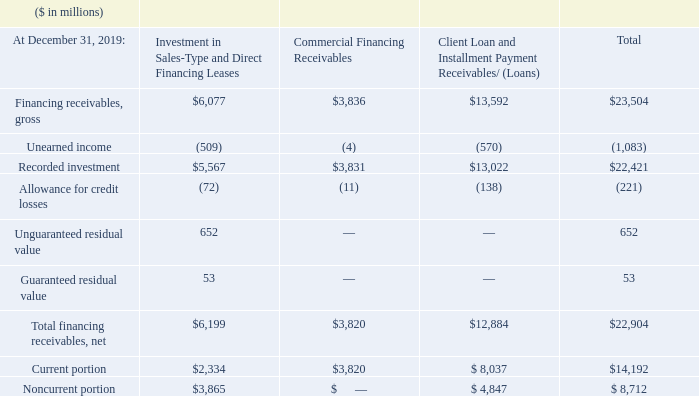Financing receivables primarily consist of client loan and installment payment receivables (loans), investment in sales-type and direct financing leases, and commercial financing receivables. Client loan and installment payment receivables (loans) are provided primarily to clients to finance the purchase of hardware, software and services.
Payment terms on these financing arrangements are generally for terms up to seven years. Client loans and installment payment financing contracts are priced independently at competitive market rates. Investment in sales-type and direct financing leases relates principally to the company’s Systems products and are for terms ranging generally from two to six years.
Commercial financing receivables relate primarily to inventory and accounts receivable financing for dealers and remarketers of IBM and OEM products. Payment terms for inventory and accounts receivable financing generally range from 30 to 90 days.
What is the payment term for financing arrangements Payment terms on these financing arrangements are generally for terms up to seven years. client loans and installment payment financing contracts are priced independently at competitive market rates. What is the purpose of Client loan and installment payment receivables (loans)? Client loan and installment payment receivables (loans) are provided primarily to clients to finance the purchase of hardware, software and services. What is the payment term for inventory and accounts receivable financing? Payment terms for inventory and accounts receivable financing generally range from 30 to 90 days. What is the average of Total financing receivables, net?
Answer scale should be: million. (6,199+3,820+12,884) / 3
Answer: 7634.33. What is the average of Unearned income?
Answer scale should be: million. 1,083/ 3
Answer: 361. What is the average of Recorded investment?
Answer scale should be: million. (5,567+3,831+13,022) / 3
Answer: 7473.33. 